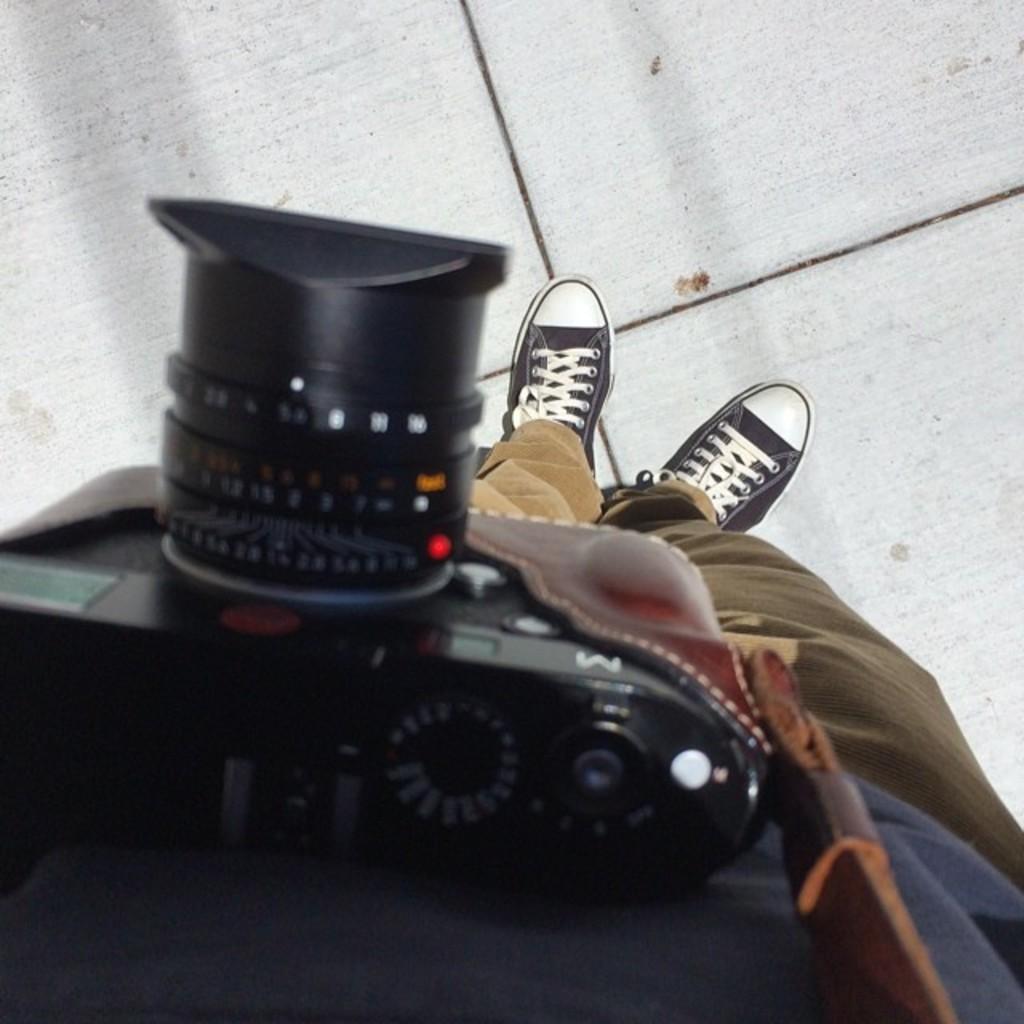Describe this image in one or two sentences. There is a person standing on the surface and we can see camera with belt. 